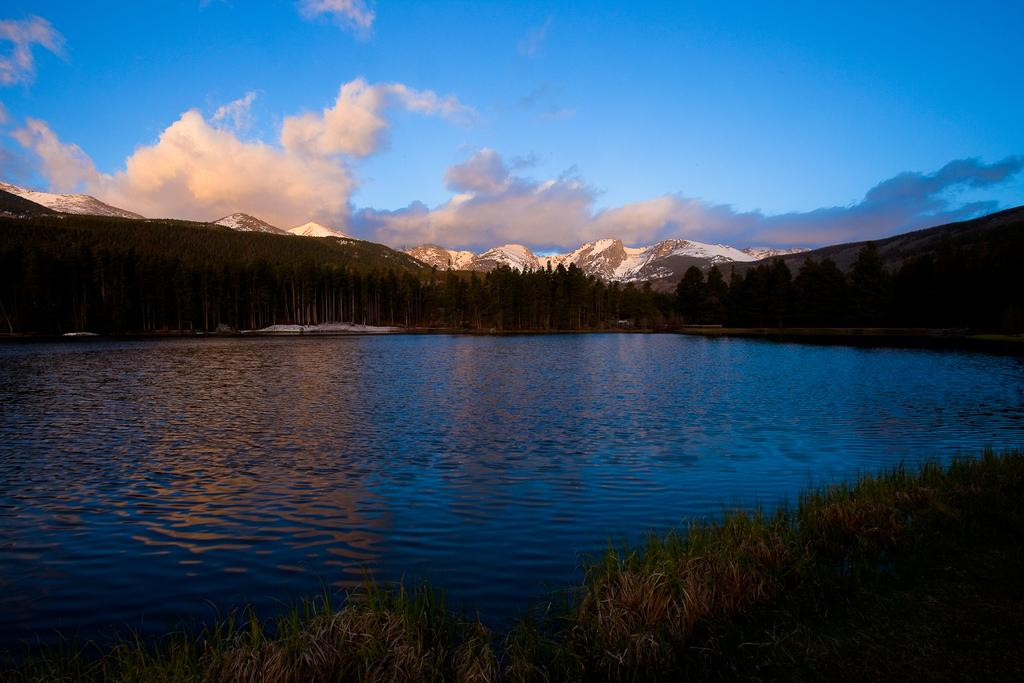What is one of the natural elements present in the image? There is water in the image. What type of vegetation can be seen in the image? There is grass and trees in the image. What geographical feature is visible in the background of the image? There are mountains in the background of the image. What part of the sky is visible in the image? The sky is visible in the image. What atmospheric feature can be seen in the sky? Clouds are present in the sky. What type of laborer is working on the stone in the image? There is no laborer or stone present in the image. 